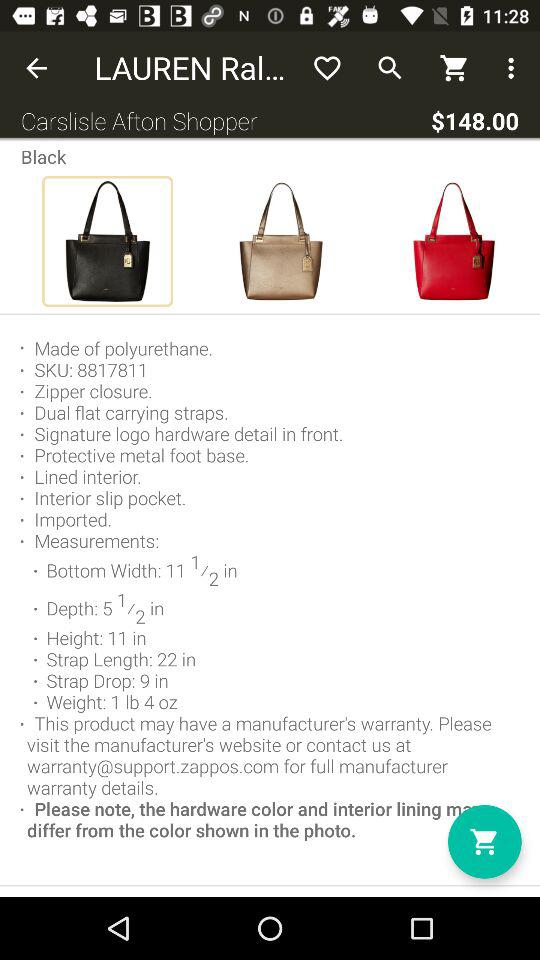How many different colors of tote bags are available?
Answer the question using a single word or phrase. 3 